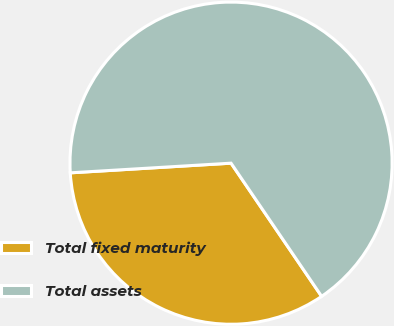Convert chart. <chart><loc_0><loc_0><loc_500><loc_500><pie_chart><fcel>Total fixed maturity<fcel>Total assets<nl><fcel>33.55%<fcel>66.45%<nl></chart> 